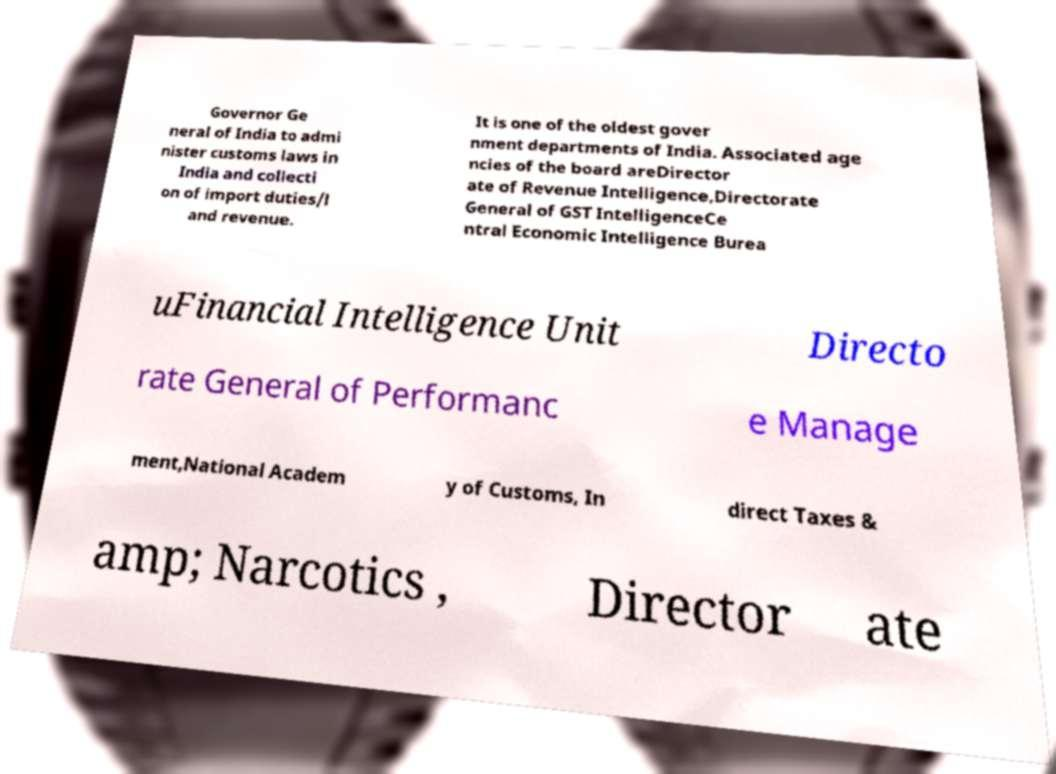Can you accurately transcribe the text from the provided image for me? Governor Ge neral of India to admi nister customs laws in India and collecti on of import duties/l and revenue. It is one of the oldest gover nment departments of India. Associated age ncies of the board areDirector ate of Revenue Intelligence,Directorate General of GST IntelligenceCe ntral Economic Intelligence Burea uFinancial Intelligence Unit Directo rate General of Performanc e Manage ment,National Academ y of Customs, In direct Taxes & amp; Narcotics , Director ate 